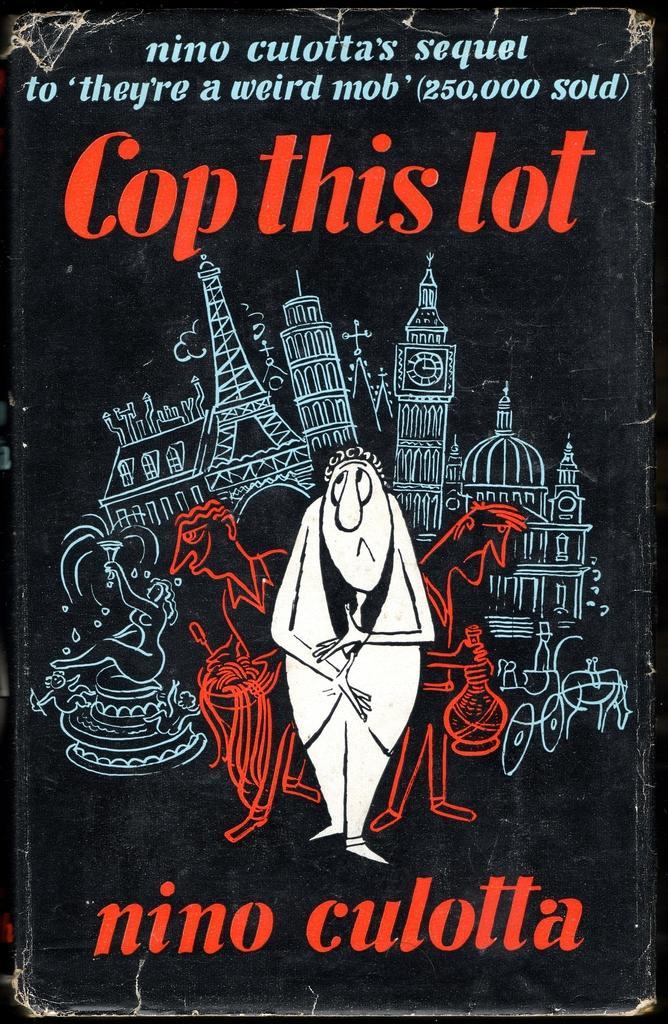In one or two sentences, can you explain what this image depicts? This is a poster and in this poster we can see buildings, horse cart, some people and text. 